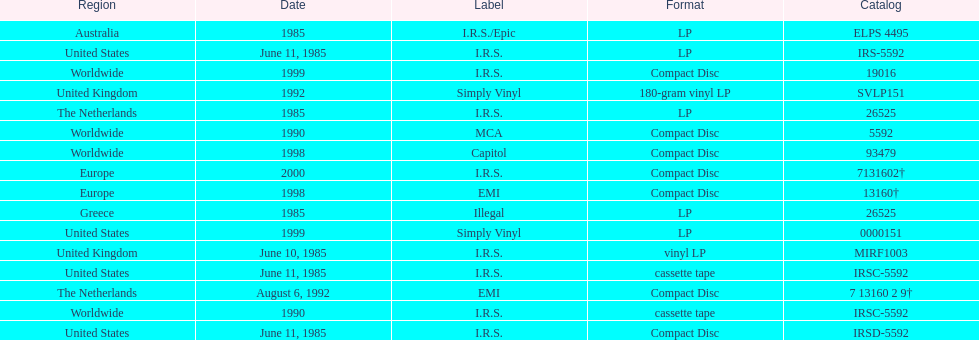Which country or region had the most releases? Worldwide. 